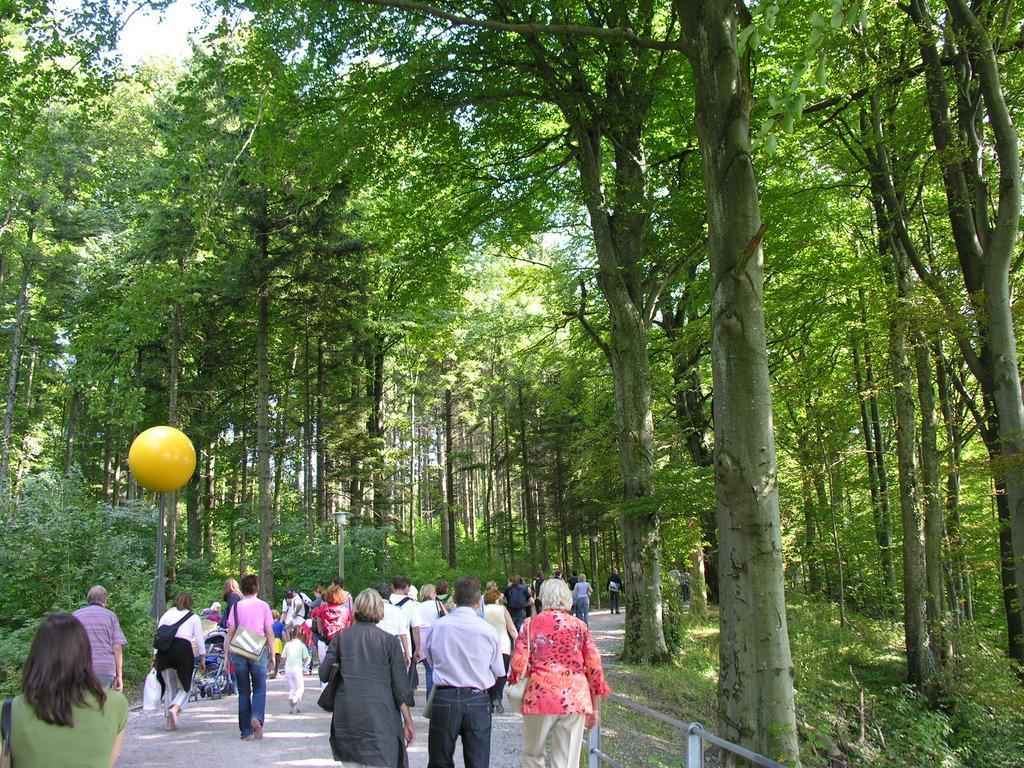Please provide a concise description of this image. In this image I can see number of persons are standing on the road and a yellow colored ball over here. I can see the railing and number of trees which are green in color. In the background I can see the sky. 